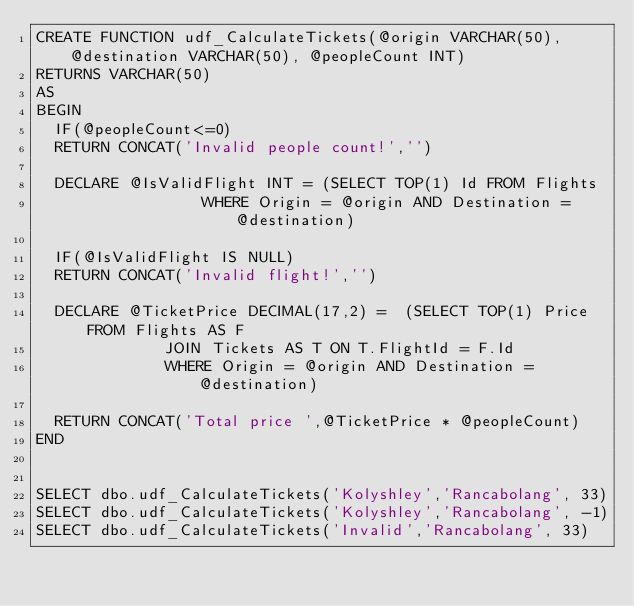<code> <loc_0><loc_0><loc_500><loc_500><_SQL_>CREATE FUNCTION udf_CalculateTickets(@origin VARCHAR(50), @destination VARCHAR(50), @peopleCount INT)  
RETURNS VARCHAR(50)
AS
BEGIN
	IF(@peopleCount<=0)
	RETURN CONCAT('Invalid people count!','')

	DECLARE @IsValidFlight INT = (SELECT TOP(1) Id FROM Flights
									WHERE Origin = @origin AND Destination = @destination)

	IF(@IsValidFlight IS NULL)
	RETURN CONCAT('Invalid flight!','')

	DECLARE @TicketPrice DECIMAL(17,2) =  (SELECT TOP(1) Price FROM Flights AS F
							JOIN Tickets AS T ON T.FlightId = F.Id
							WHERE Origin = @origin AND Destination = @destination)

	RETURN CONCAT('Total price ',@TicketPrice * @peopleCount)
END


SELECT dbo.udf_CalculateTickets('Kolyshley','Rancabolang', 33)
SELECT dbo.udf_CalculateTickets('Kolyshley','Rancabolang', -1)
SELECT dbo.udf_CalculateTickets('Invalid','Rancabolang', 33)</code> 